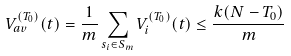<formula> <loc_0><loc_0><loc_500><loc_500>V _ { a v } ^ { ( T _ { 0 } ) } ( t ) = \frac { 1 } { m } \sum _ { s _ { i } \in S _ { m } } V _ { i } ^ { ( T _ { 0 } ) } ( t ) \leq \frac { k ( N - T _ { 0 } ) } { m }</formula> 